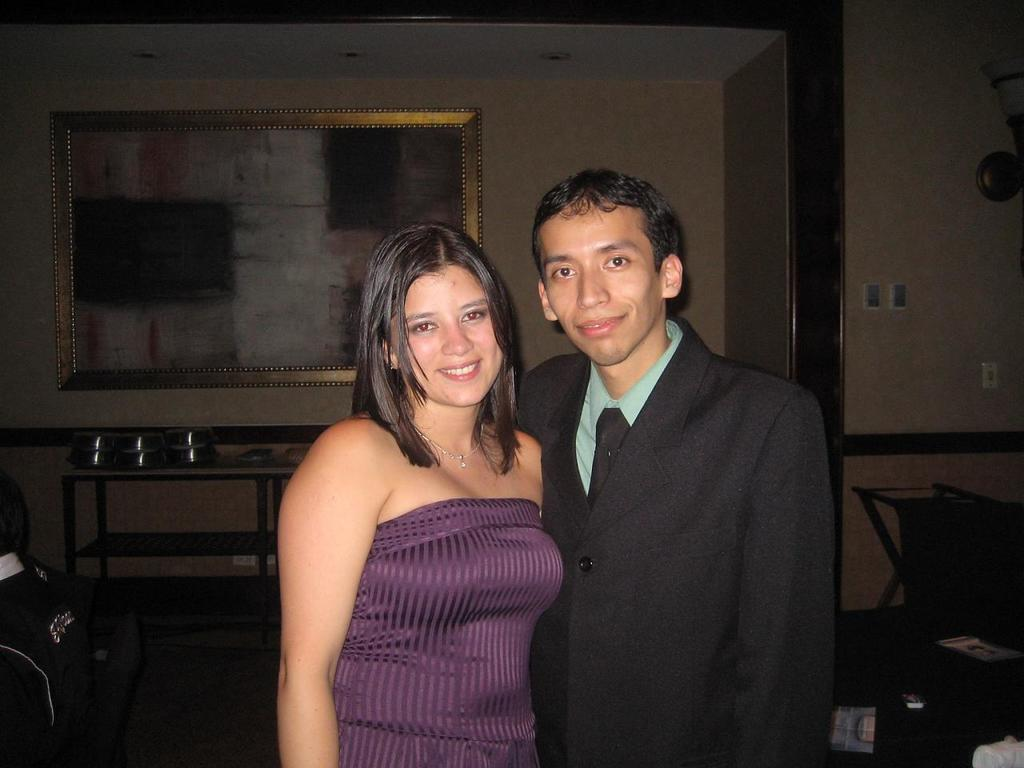Who can be seen in the image? There is a couple standing in the image. What is located in the background of the image? There is a table and a wall visible in the background of the image. What school is the couple attending in the image? There is no school present in the image, and the couple's educational status is not mentioned. 